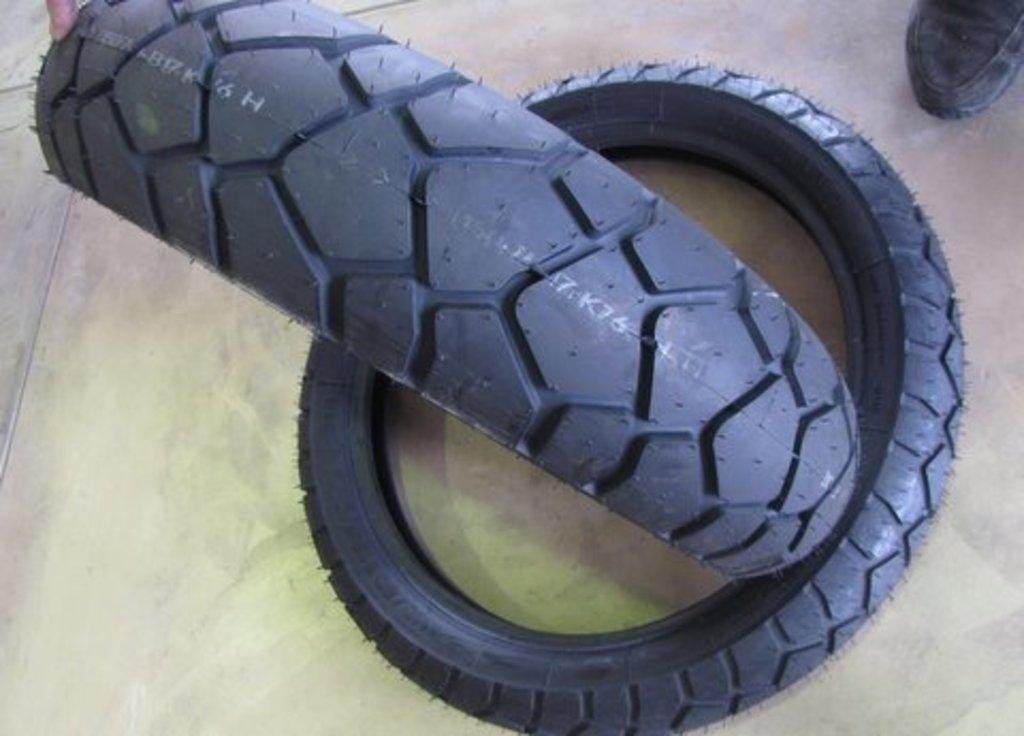Can you describe this image briefly? As we can see in the image there are tyres and black color shoes. 